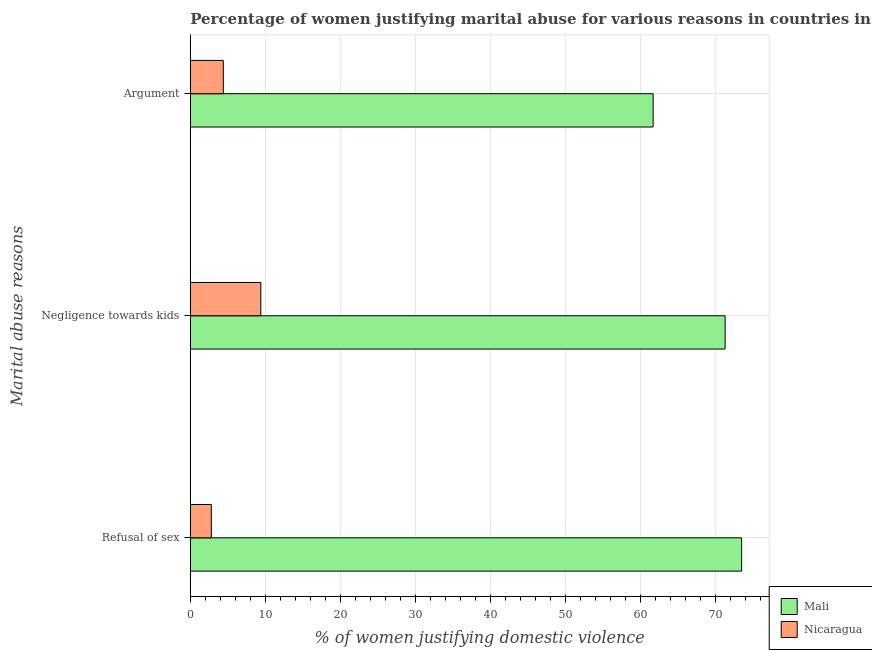How many different coloured bars are there?
Offer a very short reply. 2. Are the number of bars per tick equal to the number of legend labels?
Ensure brevity in your answer.  Yes. How many bars are there on the 3rd tick from the top?
Provide a short and direct response. 2. What is the label of the 1st group of bars from the top?
Give a very brief answer. Argument. What is the percentage of women justifying domestic violence due to arguments in Nicaragua?
Offer a terse response. 4.4. Across all countries, what is the maximum percentage of women justifying domestic violence due to arguments?
Offer a terse response. 61.7. In which country was the percentage of women justifying domestic violence due to arguments maximum?
Offer a terse response. Mali. In which country was the percentage of women justifying domestic violence due to negligence towards kids minimum?
Your response must be concise. Nicaragua. What is the total percentage of women justifying domestic violence due to refusal of sex in the graph?
Your answer should be very brief. 76.3. What is the difference between the percentage of women justifying domestic violence due to refusal of sex in Nicaragua and that in Mali?
Provide a short and direct response. -70.7. What is the difference between the percentage of women justifying domestic violence due to arguments in Nicaragua and the percentage of women justifying domestic violence due to negligence towards kids in Mali?
Offer a terse response. -66.9. What is the average percentage of women justifying domestic violence due to refusal of sex per country?
Your answer should be compact. 38.15. What is the ratio of the percentage of women justifying domestic violence due to refusal of sex in Mali to that in Nicaragua?
Offer a terse response. 26.25. What is the difference between the highest and the second highest percentage of women justifying domestic violence due to negligence towards kids?
Offer a terse response. 61.9. What is the difference between the highest and the lowest percentage of women justifying domestic violence due to negligence towards kids?
Offer a terse response. 61.9. In how many countries, is the percentage of women justifying domestic violence due to refusal of sex greater than the average percentage of women justifying domestic violence due to refusal of sex taken over all countries?
Offer a terse response. 1. What does the 2nd bar from the top in Negligence towards kids represents?
Keep it short and to the point. Mali. What does the 2nd bar from the bottom in Negligence towards kids represents?
Your answer should be very brief. Nicaragua. Is it the case that in every country, the sum of the percentage of women justifying domestic violence due to refusal of sex and percentage of women justifying domestic violence due to negligence towards kids is greater than the percentage of women justifying domestic violence due to arguments?
Provide a short and direct response. Yes. Are all the bars in the graph horizontal?
Keep it short and to the point. Yes. How many countries are there in the graph?
Ensure brevity in your answer.  2. What is the difference between two consecutive major ticks on the X-axis?
Your answer should be very brief. 10. Does the graph contain grids?
Offer a very short reply. Yes. Where does the legend appear in the graph?
Your response must be concise. Bottom right. How many legend labels are there?
Provide a succinct answer. 2. How are the legend labels stacked?
Ensure brevity in your answer.  Vertical. What is the title of the graph?
Keep it short and to the point. Percentage of women justifying marital abuse for various reasons in countries in 2001. What is the label or title of the X-axis?
Ensure brevity in your answer.  % of women justifying domestic violence. What is the label or title of the Y-axis?
Offer a very short reply. Marital abuse reasons. What is the % of women justifying domestic violence of Mali in Refusal of sex?
Your answer should be compact. 73.5. What is the % of women justifying domestic violence in Mali in Negligence towards kids?
Give a very brief answer. 71.3. What is the % of women justifying domestic violence in Nicaragua in Negligence towards kids?
Offer a very short reply. 9.4. What is the % of women justifying domestic violence in Mali in Argument?
Provide a short and direct response. 61.7. What is the % of women justifying domestic violence in Nicaragua in Argument?
Make the answer very short. 4.4. Across all Marital abuse reasons, what is the maximum % of women justifying domestic violence in Mali?
Keep it short and to the point. 73.5. Across all Marital abuse reasons, what is the maximum % of women justifying domestic violence of Nicaragua?
Offer a very short reply. 9.4. Across all Marital abuse reasons, what is the minimum % of women justifying domestic violence of Mali?
Offer a very short reply. 61.7. Across all Marital abuse reasons, what is the minimum % of women justifying domestic violence of Nicaragua?
Offer a very short reply. 2.8. What is the total % of women justifying domestic violence in Mali in the graph?
Your answer should be very brief. 206.5. What is the difference between the % of women justifying domestic violence in Mali in Refusal of sex and that in Negligence towards kids?
Provide a short and direct response. 2.2. What is the difference between the % of women justifying domestic violence in Mali in Refusal of sex and that in Argument?
Keep it short and to the point. 11.8. What is the difference between the % of women justifying domestic violence of Nicaragua in Refusal of sex and that in Argument?
Offer a very short reply. -1.6. What is the difference between the % of women justifying domestic violence in Mali in Negligence towards kids and that in Argument?
Make the answer very short. 9.6. What is the difference between the % of women justifying domestic violence of Mali in Refusal of sex and the % of women justifying domestic violence of Nicaragua in Negligence towards kids?
Give a very brief answer. 64.1. What is the difference between the % of women justifying domestic violence in Mali in Refusal of sex and the % of women justifying domestic violence in Nicaragua in Argument?
Make the answer very short. 69.1. What is the difference between the % of women justifying domestic violence in Mali in Negligence towards kids and the % of women justifying domestic violence in Nicaragua in Argument?
Keep it short and to the point. 66.9. What is the average % of women justifying domestic violence in Mali per Marital abuse reasons?
Provide a succinct answer. 68.83. What is the average % of women justifying domestic violence in Nicaragua per Marital abuse reasons?
Keep it short and to the point. 5.53. What is the difference between the % of women justifying domestic violence in Mali and % of women justifying domestic violence in Nicaragua in Refusal of sex?
Provide a succinct answer. 70.7. What is the difference between the % of women justifying domestic violence of Mali and % of women justifying domestic violence of Nicaragua in Negligence towards kids?
Make the answer very short. 61.9. What is the difference between the % of women justifying domestic violence of Mali and % of women justifying domestic violence of Nicaragua in Argument?
Give a very brief answer. 57.3. What is the ratio of the % of women justifying domestic violence of Mali in Refusal of sex to that in Negligence towards kids?
Provide a succinct answer. 1.03. What is the ratio of the % of women justifying domestic violence of Nicaragua in Refusal of sex to that in Negligence towards kids?
Your answer should be very brief. 0.3. What is the ratio of the % of women justifying domestic violence in Mali in Refusal of sex to that in Argument?
Ensure brevity in your answer.  1.19. What is the ratio of the % of women justifying domestic violence in Nicaragua in Refusal of sex to that in Argument?
Ensure brevity in your answer.  0.64. What is the ratio of the % of women justifying domestic violence of Mali in Negligence towards kids to that in Argument?
Your answer should be very brief. 1.16. What is the ratio of the % of women justifying domestic violence in Nicaragua in Negligence towards kids to that in Argument?
Make the answer very short. 2.14. What is the difference between the highest and the second highest % of women justifying domestic violence of Mali?
Offer a very short reply. 2.2. 